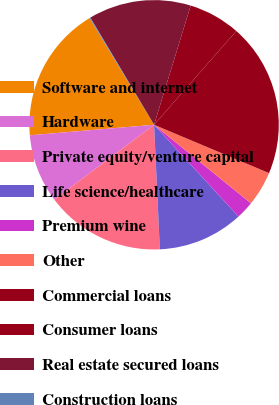Convert chart to OTSL. <chart><loc_0><loc_0><loc_500><loc_500><pie_chart><fcel>Software and internet<fcel>Hardware<fcel>Private equity/venture capital<fcel>Life science/healthcare<fcel>Premium wine<fcel>Other<fcel>Commercial loans<fcel>Consumer loans<fcel>Real estate secured loans<fcel>Construction loans<nl><fcel>17.68%<fcel>8.9%<fcel>15.49%<fcel>11.1%<fcel>2.32%<fcel>4.51%<fcel>19.88%<fcel>6.71%<fcel>13.29%<fcel>0.12%<nl></chart> 